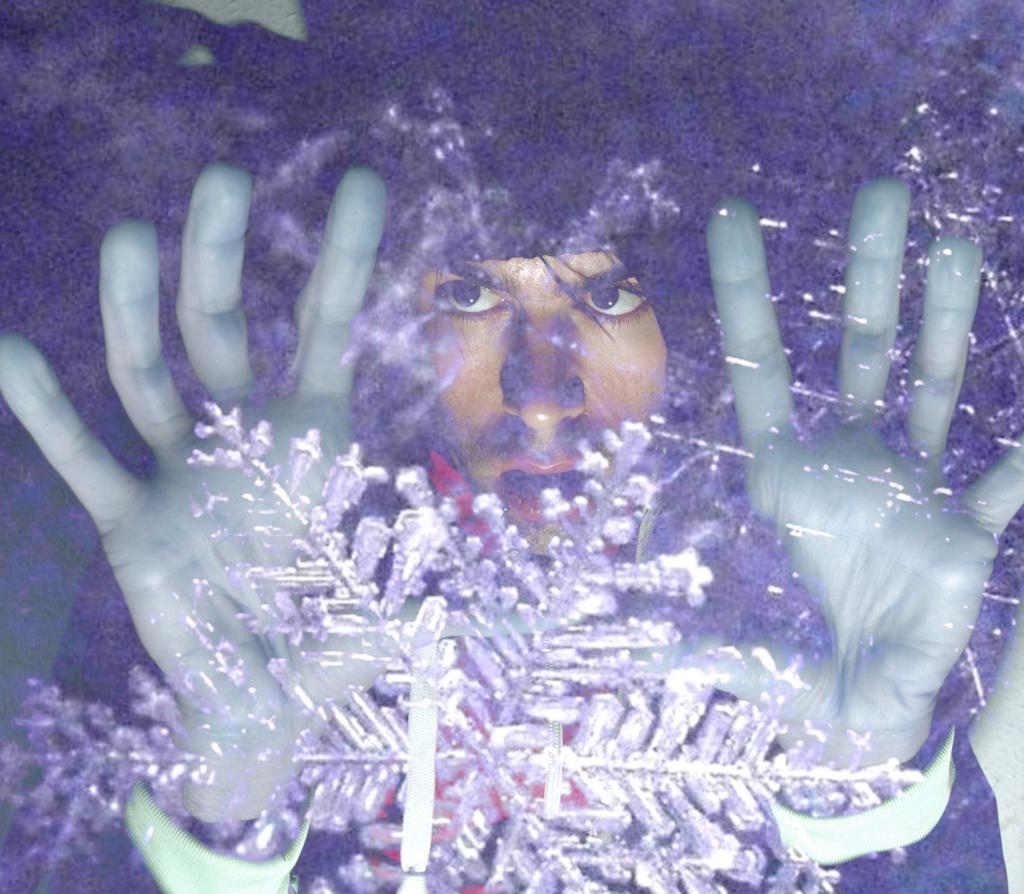What type of object can be seen in the image? There is a decorative item in the image. What is the glass used for in the image? The glass is used to see through in the image. Can you describe what is visible through the glass? A person is visible through the glass in the image. What type of oatmeal is being served in the image? There is no oatmeal present in the image. What is the selection of items available for the person to choose from in the image? The image does not show a selection of items; it only shows a decorative item and a glass with a person visible through it. 